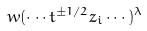Convert formula to latex. <formula><loc_0><loc_0><loc_500><loc_500>w ( \cdots t ^ { \pm 1 / 2 } z _ { i } \cdots ) ^ { \lambda }</formula> 